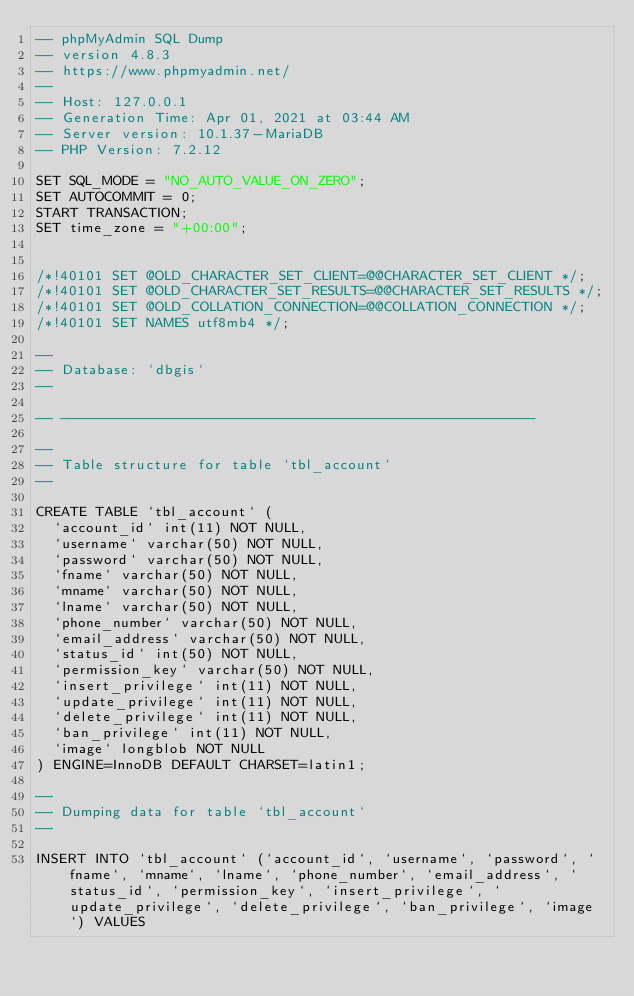<code> <loc_0><loc_0><loc_500><loc_500><_SQL_>-- phpMyAdmin SQL Dump
-- version 4.8.3
-- https://www.phpmyadmin.net/
--
-- Host: 127.0.0.1
-- Generation Time: Apr 01, 2021 at 03:44 AM
-- Server version: 10.1.37-MariaDB
-- PHP Version: 7.2.12

SET SQL_MODE = "NO_AUTO_VALUE_ON_ZERO";
SET AUTOCOMMIT = 0;
START TRANSACTION;
SET time_zone = "+00:00";


/*!40101 SET @OLD_CHARACTER_SET_CLIENT=@@CHARACTER_SET_CLIENT */;
/*!40101 SET @OLD_CHARACTER_SET_RESULTS=@@CHARACTER_SET_RESULTS */;
/*!40101 SET @OLD_COLLATION_CONNECTION=@@COLLATION_CONNECTION */;
/*!40101 SET NAMES utf8mb4 */;

--
-- Database: `dbgis`
--

-- --------------------------------------------------------

--
-- Table structure for table `tbl_account`
--

CREATE TABLE `tbl_account` (
  `account_id` int(11) NOT NULL,
  `username` varchar(50) NOT NULL,
  `password` varchar(50) NOT NULL,
  `fname` varchar(50) NOT NULL,
  `mname` varchar(50) NOT NULL,
  `lname` varchar(50) NOT NULL,
  `phone_number` varchar(50) NOT NULL,
  `email_address` varchar(50) NOT NULL,
  `status_id` int(50) NOT NULL,
  `permission_key` varchar(50) NOT NULL,
  `insert_privilege` int(11) NOT NULL,
  `update_privilege` int(11) NOT NULL,
  `delete_privilege` int(11) NOT NULL,
  `ban_privilege` int(11) NOT NULL,
  `image` longblob NOT NULL
) ENGINE=InnoDB DEFAULT CHARSET=latin1;

--
-- Dumping data for table `tbl_account`
--

INSERT INTO `tbl_account` (`account_id`, `username`, `password`, `fname`, `mname`, `lname`, `phone_number`, `email_address`, `status_id`, `permission_key`, `insert_privilege`, `update_privilege`, `delete_privilege`, `ban_privilege`, `image`) VALUES</code> 